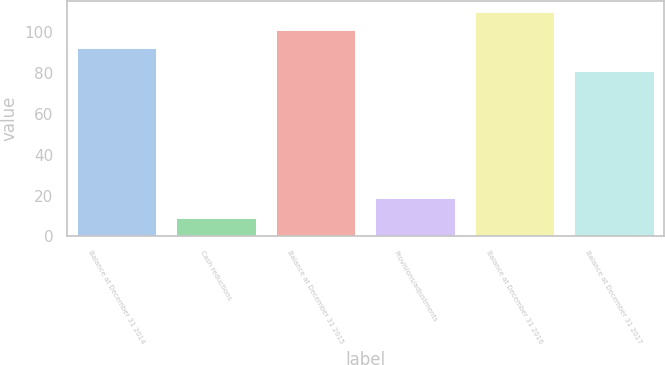Convert chart to OTSL. <chart><loc_0><loc_0><loc_500><loc_500><bar_chart><fcel>Balance at December 31 2014<fcel>Cash reductions<fcel>Balance at December 31 2015<fcel>Provisions/adjustments<fcel>Balance at December 31 2016<fcel>Balance at December 31 2017<nl><fcel>92<fcel>9<fcel>100.9<fcel>19<fcel>109.8<fcel>81<nl></chart> 